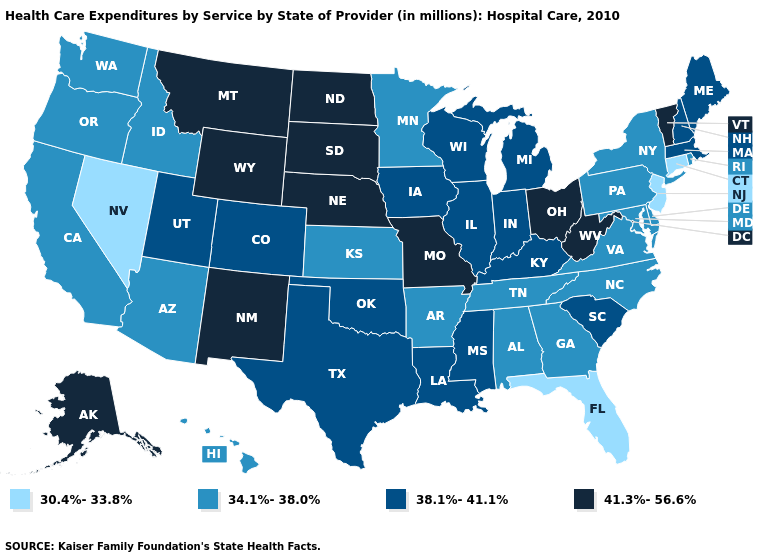Which states hav the highest value in the Northeast?
Be succinct. Vermont. Name the states that have a value in the range 38.1%-41.1%?
Answer briefly. Colorado, Illinois, Indiana, Iowa, Kentucky, Louisiana, Maine, Massachusetts, Michigan, Mississippi, New Hampshire, Oklahoma, South Carolina, Texas, Utah, Wisconsin. Does Alaska have a higher value than Nebraska?
Be succinct. No. Does West Virginia have a lower value than Michigan?
Short answer required. No. Among the states that border Delaware , does Pennsylvania have the highest value?
Short answer required. Yes. Name the states that have a value in the range 38.1%-41.1%?
Short answer required. Colorado, Illinois, Indiana, Iowa, Kentucky, Louisiana, Maine, Massachusetts, Michigan, Mississippi, New Hampshire, Oklahoma, South Carolina, Texas, Utah, Wisconsin. Among the states that border West Virginia , which have the highest value?
Concise answer only. Ohio. Does the map have missing data?
Keep it brief. No. Name the states that have a value in the range 34.1%-38.0%?
Keep it brief. Alabama, Arizona, Arkansas, California, Delaware, Georgia, Hawaii, Idaho, Kansas, Maryland, Minnesota, New York, North Carolina, Oregon, Pennsylvania, Rhode Island, Tennessee, Virginia, Washington. Does Wyoming have a higher value than North Dakota?
Write a very short answer. No. Which states hav the highest value in the West?
Give a very brief answer. Alaska, Montana, New Mexico, Wyoming. Name the states that have a value in the range 34.1%-38.0%?
Concise answer only. Alabama, Arizona, Arkansas, California, Delaware, Georgia, Hawaii, Idaho, Kansas, Maryland, Minnesota, New York, North Carolina, Oregon, Pennsylvania, Rhode Island, Tennessee, Virginia, Washington. Does New Jersey have the lowest value in the USA?
Write a very short answer. Yes. Does New Jersey have a lower value than Indiana?
Answer briefly. Yes. What is the lowest value in the West?
Answer briefly. 30.4%-33.8%. 